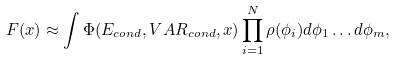<formula> <loc_0><loc_0><loc_500><loc_500>F ( x ) \approx \int \Phi ( E _ { c o n d } , V A R _ { c o n d } , x ) \prod _ { i = 1 } ^ { N } \rho ( \phi _ { i } ) d \phi _ { 1 } \dots d \phi _ { m } ,</formula> 